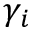Convert formula to latex. <formula><loc_0><loc_0><loc_500><loc_500>\gamma _ { i }</formula> 